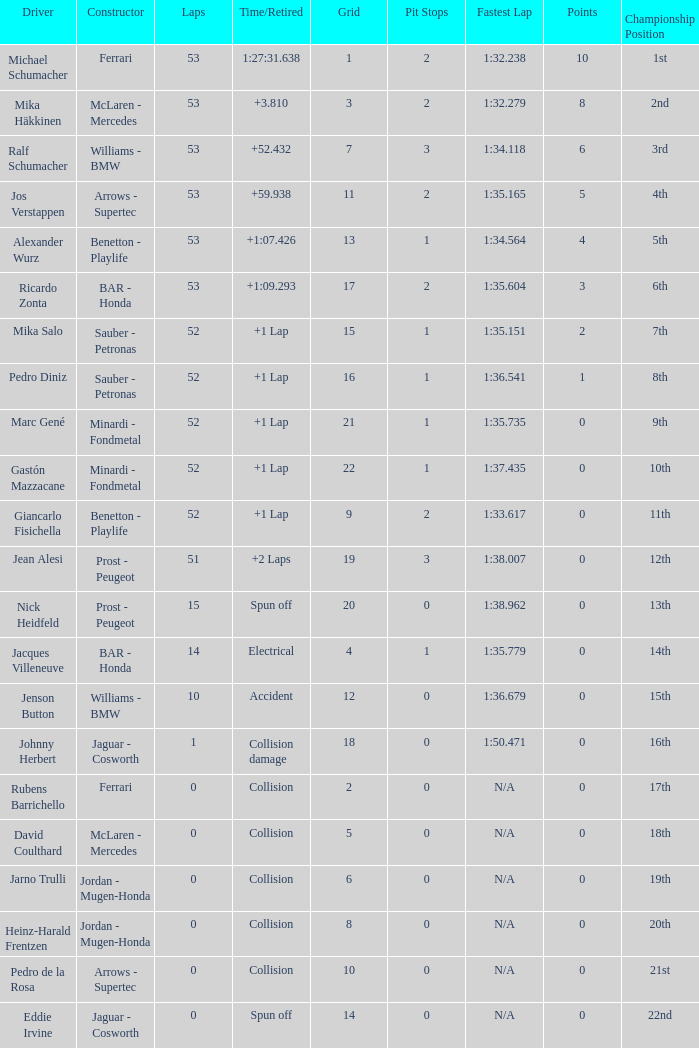What is the name of the driver with a grid less than 14, laps smaller than 53 and a Time/Retired of collision, and a Constructor of ferrari? Rubens Barrichello. 